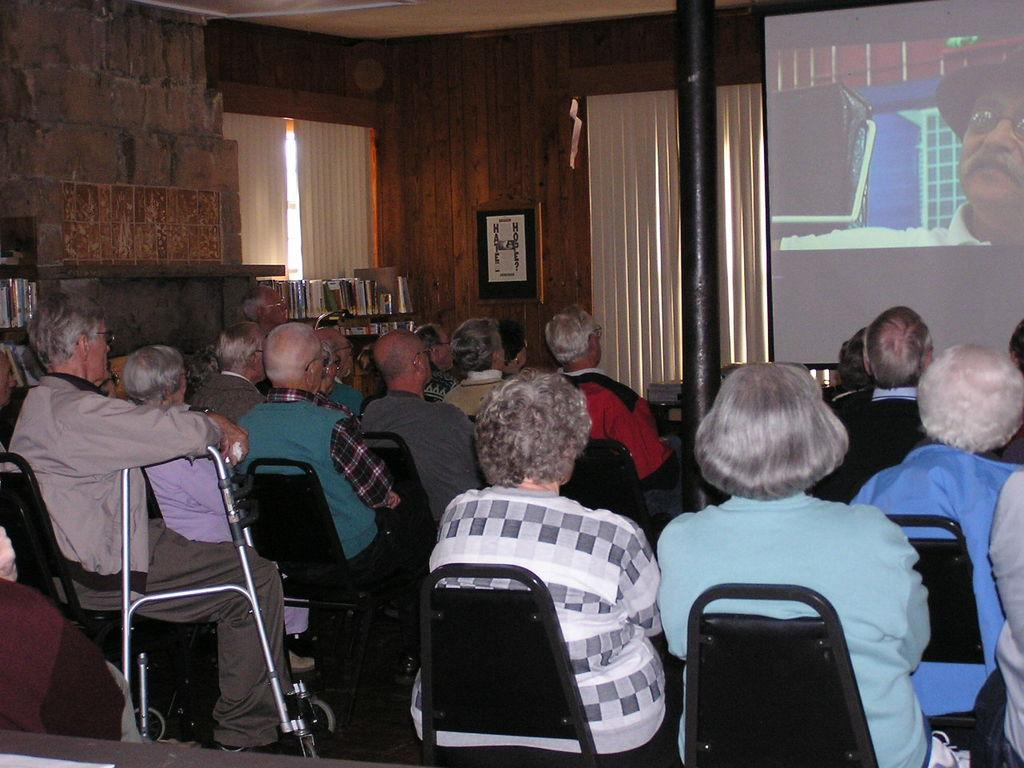What are the people in the image doing? The people in the image are sitting on chairs. What can be seen on the wall in the image? There is a screen visible in the image. What is present on the wall in the image? There is a wall in the image. What type of items can be found on the racks in the image? There are racks with books in the image. How does the milk get pulled from the station in the image? There is no milk, pulling, or station present in the image. 